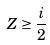Convert formula to latex. <formula><loc_0><loc_0><loc_500><loc_500>Z \geq \frac { i } { 2 }</formula> 